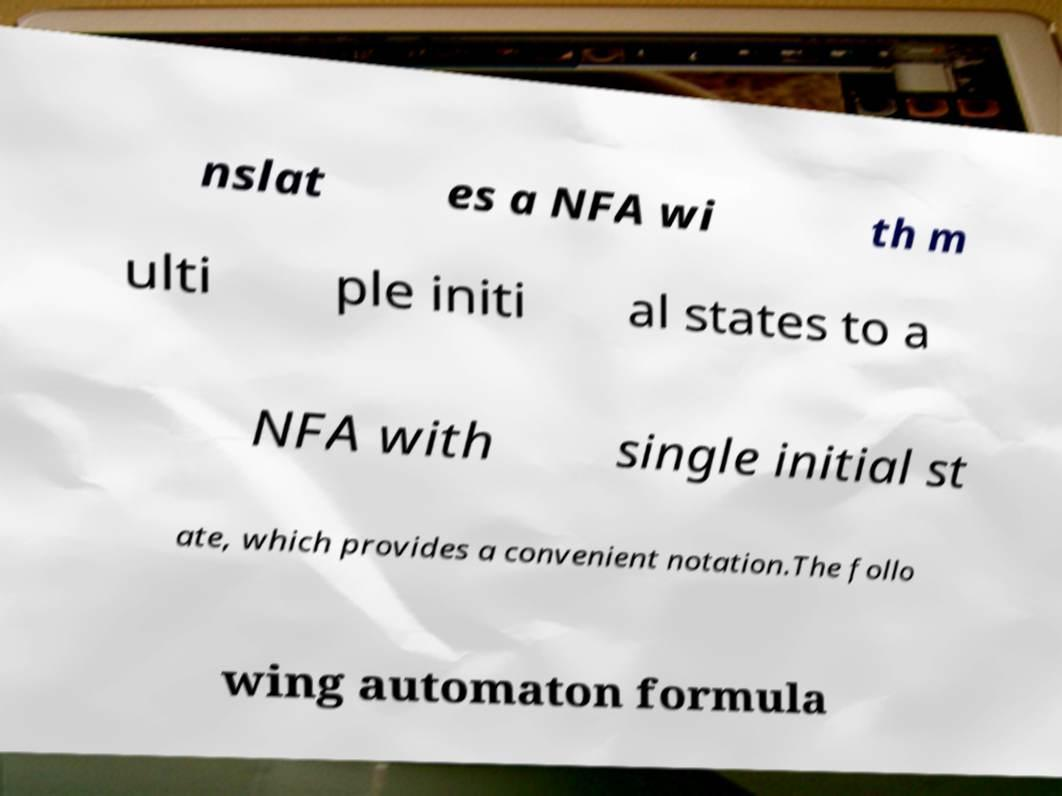Can you accurately transcribe the text from the provided image for me? nslat es a NFA wi th m ulti ple initi al states to a NFA with single initial st ate, which provides a convenient notation.The follo wing automaton formula 